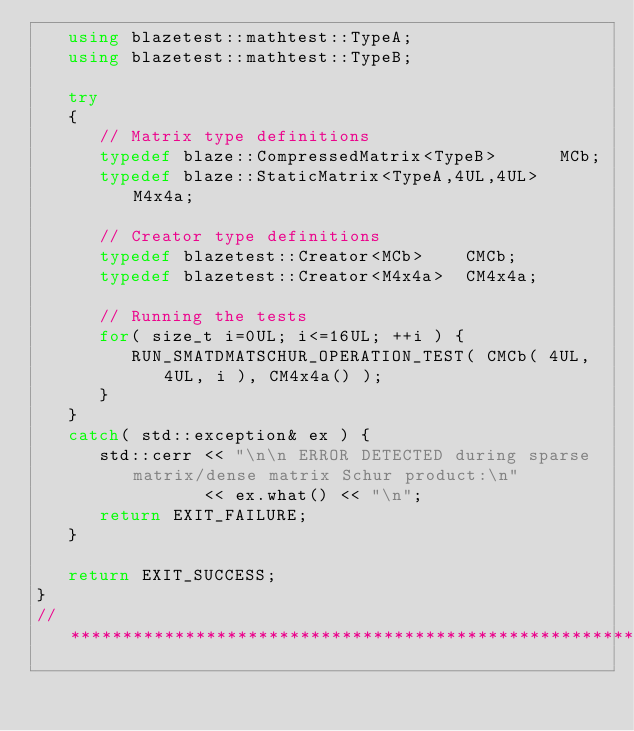Convert code to text. <code><loc_0><loc_0><loc_500><loc_500><_C++_>   using blazetest::mathtest::TypeA;
   using blazetest::mathtest::TypeB;

   try
   {
      // Matrix type definitions
      typedef blaze::CompressedMatrix<TypeB>      MCb;
      typedef blaze::StaticMatrix<TypeA,4UL,4UL>  M4x4a;

      // Creator type definitions
      typedef blazetest::Creator<MCb>    CMCb;
      typedef blazetest::Creator<M4x4a>  CM4x4a;

      // Running the tests
      for( size_t i=0UL; i<=16UL; ++i ) {
         RUN_SMATDMATSCHUR_OPERATION_TEST( CMCb( 4UL, 4UL, i ), CM4x4a() );
      }
   }
   catch( std::exception& ex ) {
      std::cerr << "\n\n ERROR DETECTED during sparse matrix/dense matrix Schur product:\n"
                << ex.what() << "\n";
      return EXIT_FAILURE;
   }

   return EXIT_SUCCESS;
}
//*************************************************************************************************
</code> 